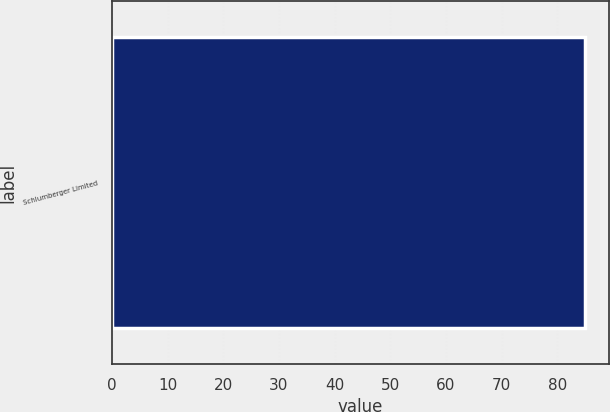Convert chart. <chart><loc_0><loc_0><loc_500><loc_500><bar_chart><fcel>Schlumberger Limited<nl><fcel>85<nl></chart> 